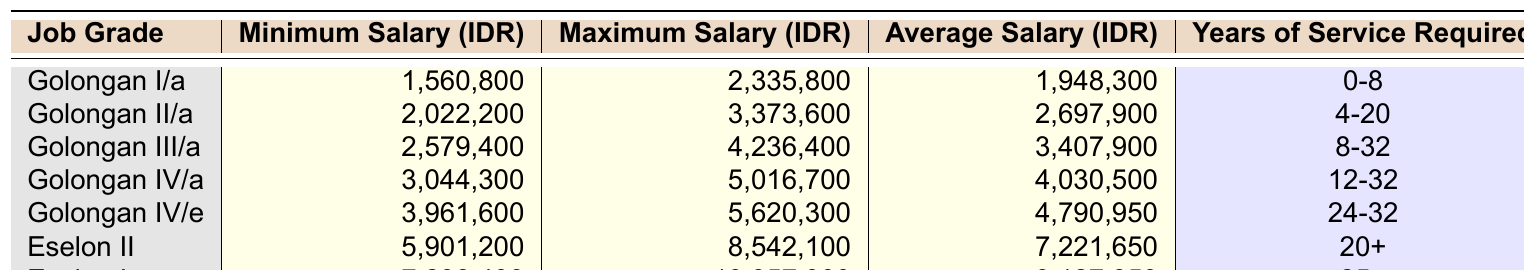What is the minimum salary for Golongan II/a? The table lists the minimum salary for Golongan II/a as 2,022,200 IDR.
Answer: 2,022,200 IDR What is the average salary of Eselon I? The average salary for Eselon I, as per the table, is 9,127,850 IDR.
Answer: 9,127,850 IDR Is the maximum salary for Golongan III/a higher than that of Golongan I/a? The maximum salary for Golongan III/a is 4,236,400 IDR, while for Golongan I/a it is 2,335,800 IDR. Since 4,236,400 is greater than 2,335,800, the statement is true.
Answer: Yes How much higher is the maximum salary of Eselon II compared to Golongan IV/a? The maximum salary for Eselon II is 8,542,100 IDR, and for Golongan IV/a, it is 5,016,700 IDR. The difference is calculated as 8,542,100 - 5,016,700 = 3,525,400 IDR.
Answer: 3,525,400 IDR What is the total average salary of Golongan I/a and Golongan II/a? The average salaries for Golongan I/a and Golongan II/a are 1,948,300 IDR and 2,697,900 IDR, respectively. Their total average salary is 1,948,300 + 2,697,900 = 4,646,200 IDR.
Answer: 4,646,200 IDR Which job grade has the highest minimum salary and what is that amount? The job grade with the highest minimum salary is Eselon I with a minimum salary of 7,298,400 IDR.
Answer: Eselon I: 7,298,400 IDR If a civil servant has served for 10 years, which job grades can they qualify for? Based on the years of service required, they can qualify for Golongan IV/a (12-32 years), Golongan III/a (8-32 years), and Golongan II/a (4-20 years), but not for Golongan I/a (0-8 years) or Eselon positions (20+ and 25+ years).
Answer: Golongan III/a, Golongan II/a What is the difference between the average salaries of Golongan IV/e and Golongan II/a? The average salary for Golongan IV/e is 4,790,950 IDR, and for Golongan II/a it is 2,697,900 IDR. The difference is 4,790,950 - 2,697,900 = 2,093,050 IDR.
Answer: 2,093,050 IDR Is the average salary of Golongan IV/a more than 4 million IDR? The average salary for Golongan IV/a is 4,030,500 IDR, which is greater than 4 million IDR. Therefore, the statement is true.
Answer: Yes Calculate the average salary of all job grades. To find the average, sum all the average salaries: (1,948,300 + 2,697,900 + 3,407,900 + 4,030,500 + 4,790,950 + 7,221,650 + 9,127,850) = 33,224,150 IDR. Then, divide by the number of job grades (7): 33,224,150 / 7 ≈ 4,746,350 IDR.
Answer: Approximately 4,746,350 IDR 